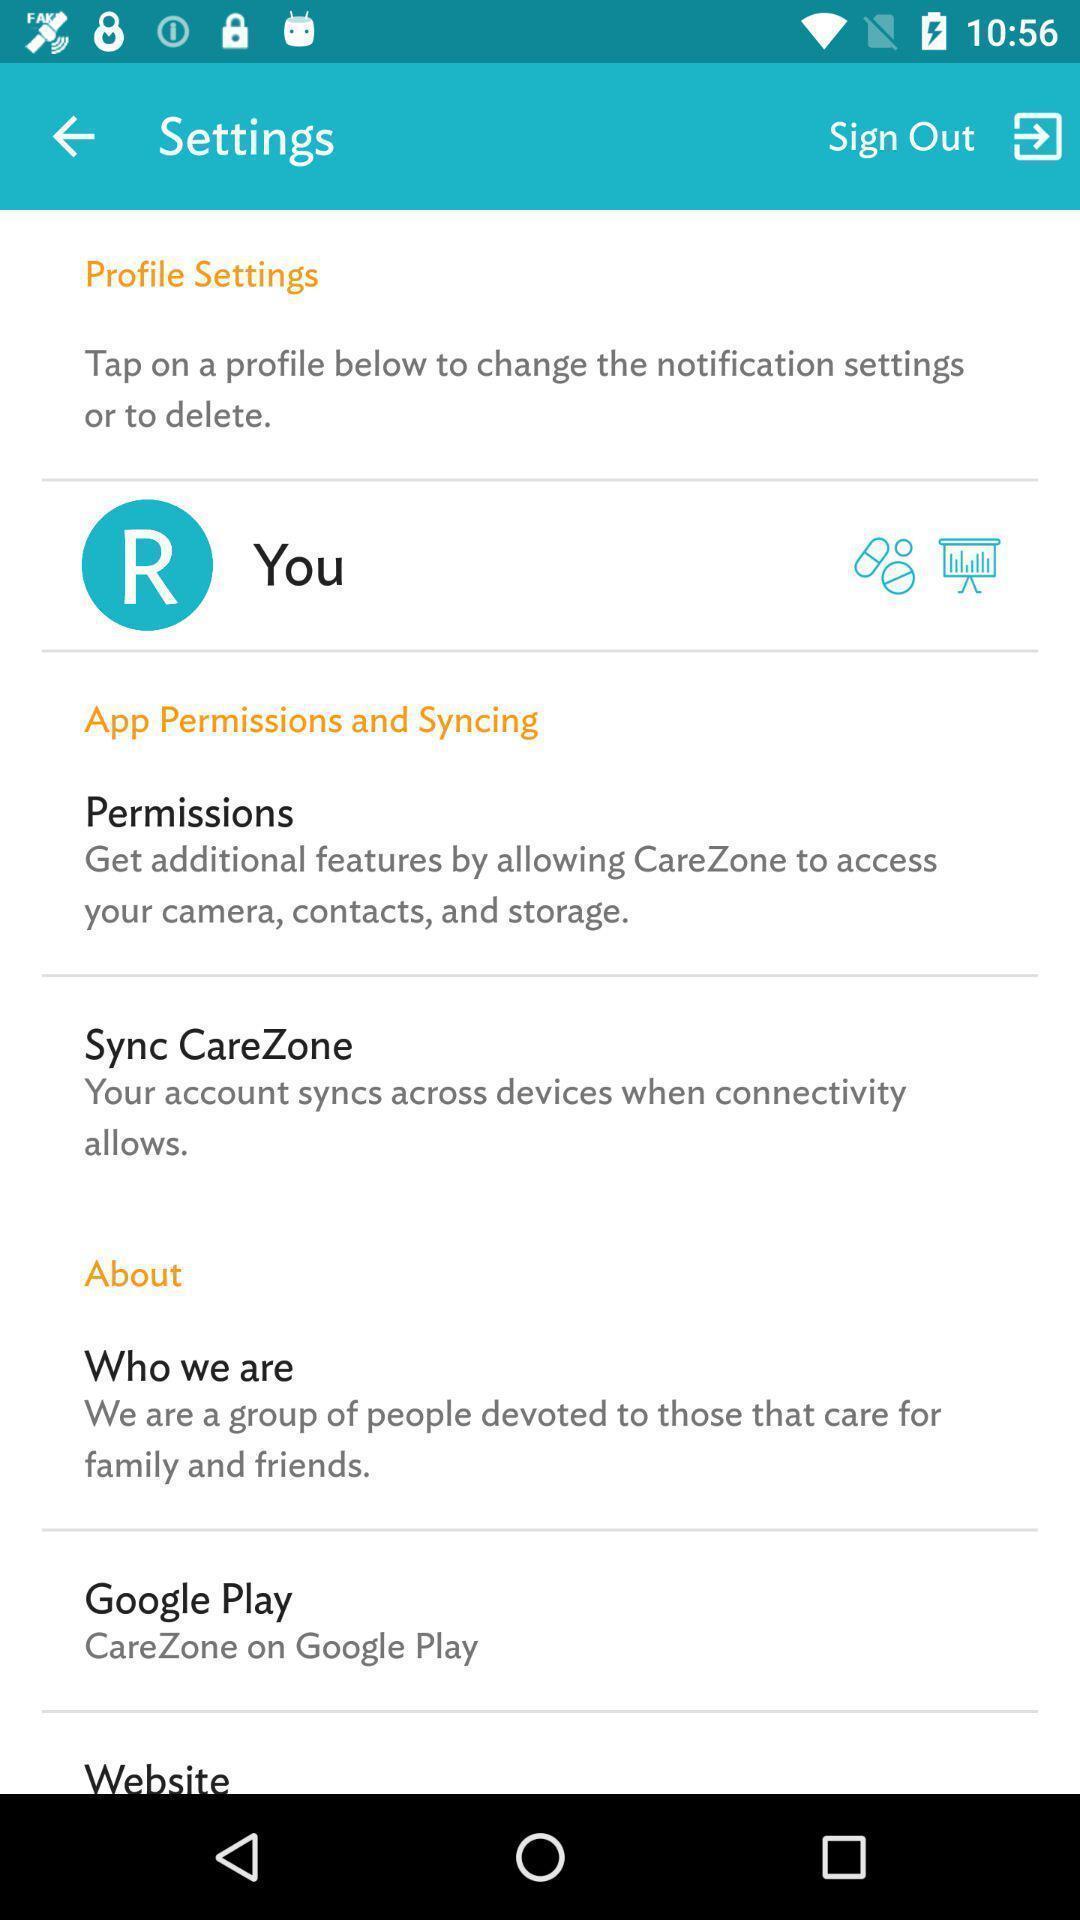Summarize the main components in this picture. Setting page displaying the various options. 